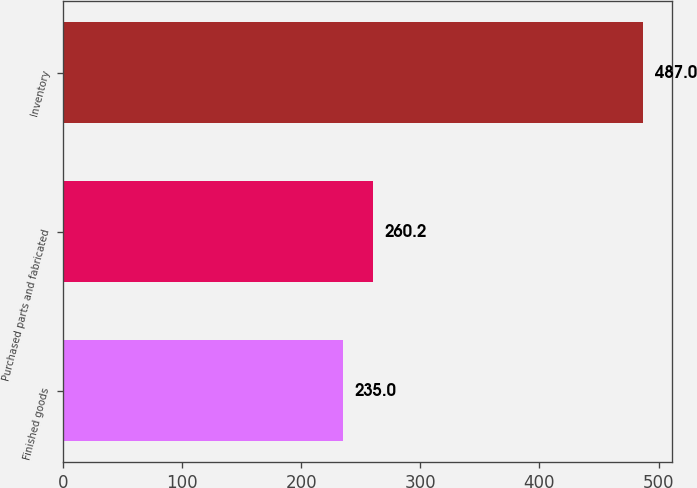Convert chart. <chart><loc_0><loc_0><loc_500><loc_500><bar_chart><fcel>Finished goods<fcel>Purchased parts and fabricated<fcel>Inventory<nl><fcel>235<fcel>260.2<fcel>487<nl></chart> 